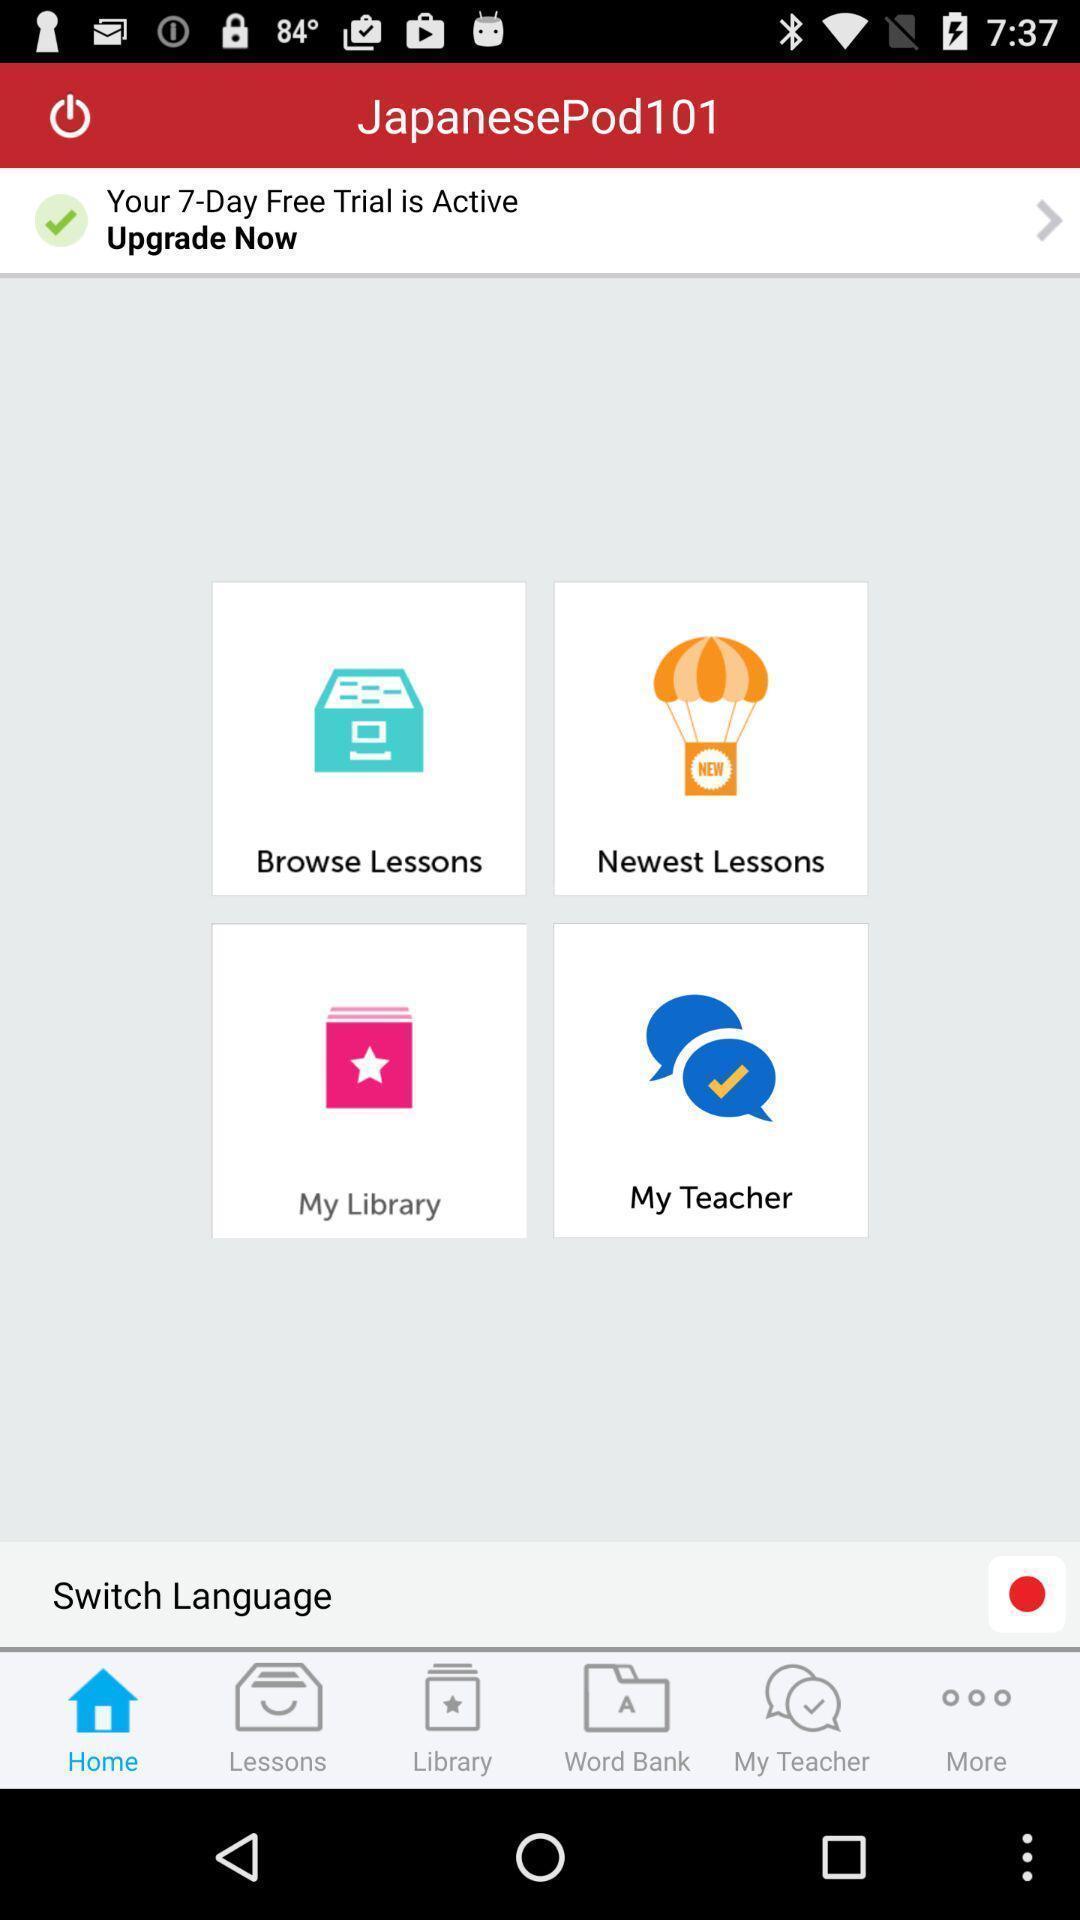Give me a narrative description of this picture. Screen shows about learning languages. 